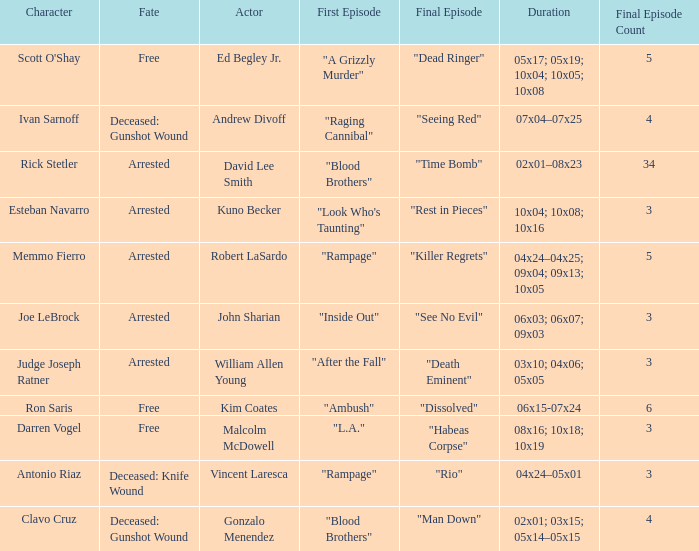What's the character with fate being deceased: knife wound Antonio Riaz. 